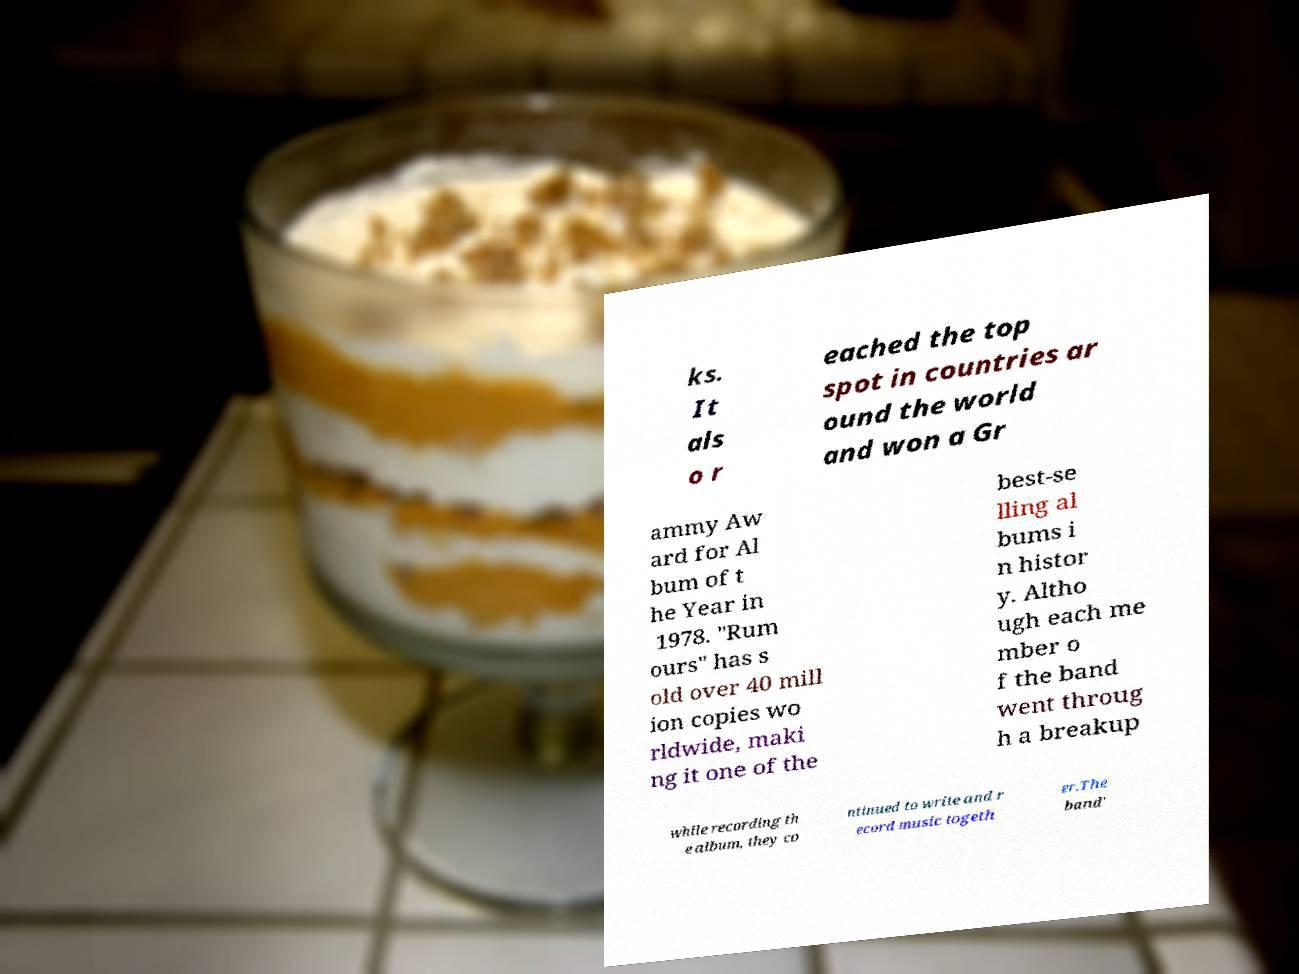Could you assist in decoding the text presented in this image and type it out clearly? ks. It als o r eached the top spot in countries ar ound the world and won a Gr ammy Aw ard for Al bum of t he Year in 1978. "Rum ours" has s old over 40 mill ion copies wo rldwide, maki ng it one of the best-se lling al bums i n histor y. Altho ugh each me mber o f the band went throug h a breakup while recording th e album, they co ntinued to write and r ecord music togeth er.The band' 